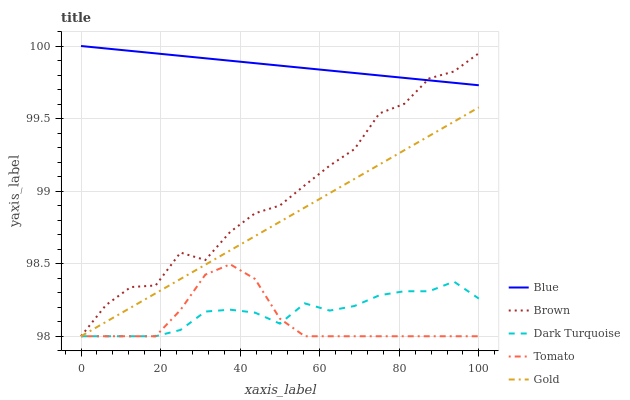Does Tomato have the minimum area under the curve?
Answer yes or no. Yes. Does Blue have the maximum area under the curve?
Answer yes or no. Yes. Does Brown have the minimum area under the curve?
Answer yes or no. No. Does Brown have the maximum area under the curve?
Answer yes or no. No. Is Blue the smoothest?
Answer yes or no. Yes. Is Brown the roughest?
Answer yes or no. Yes. Is Tomato the smoothest?
Answer yes or no. No. Is Tomato the roughest?
Answer yes or no. No. Does Brown have the lowest value?
Answer yes or no. Yes. Does Blue have the highest value?
Answer yes or no. Yes. Does Brown have the highest value?
Answer yes or no. No. Is Tomato less than Blue?
Answer yes or no. Yes. Is Blue greater than Gold?
Answer yes or no. Yes. Does Tomato intersect Dark Turquoise?
Answer yes or no. Yes. Is Tomato less than Dark Turquoise?
Answer yes or no. No. Is Tomato greater than Dark Turquoise?
Answer yes or no. No. Does Tomato intersect Blue?
Answer yes or no. No. 